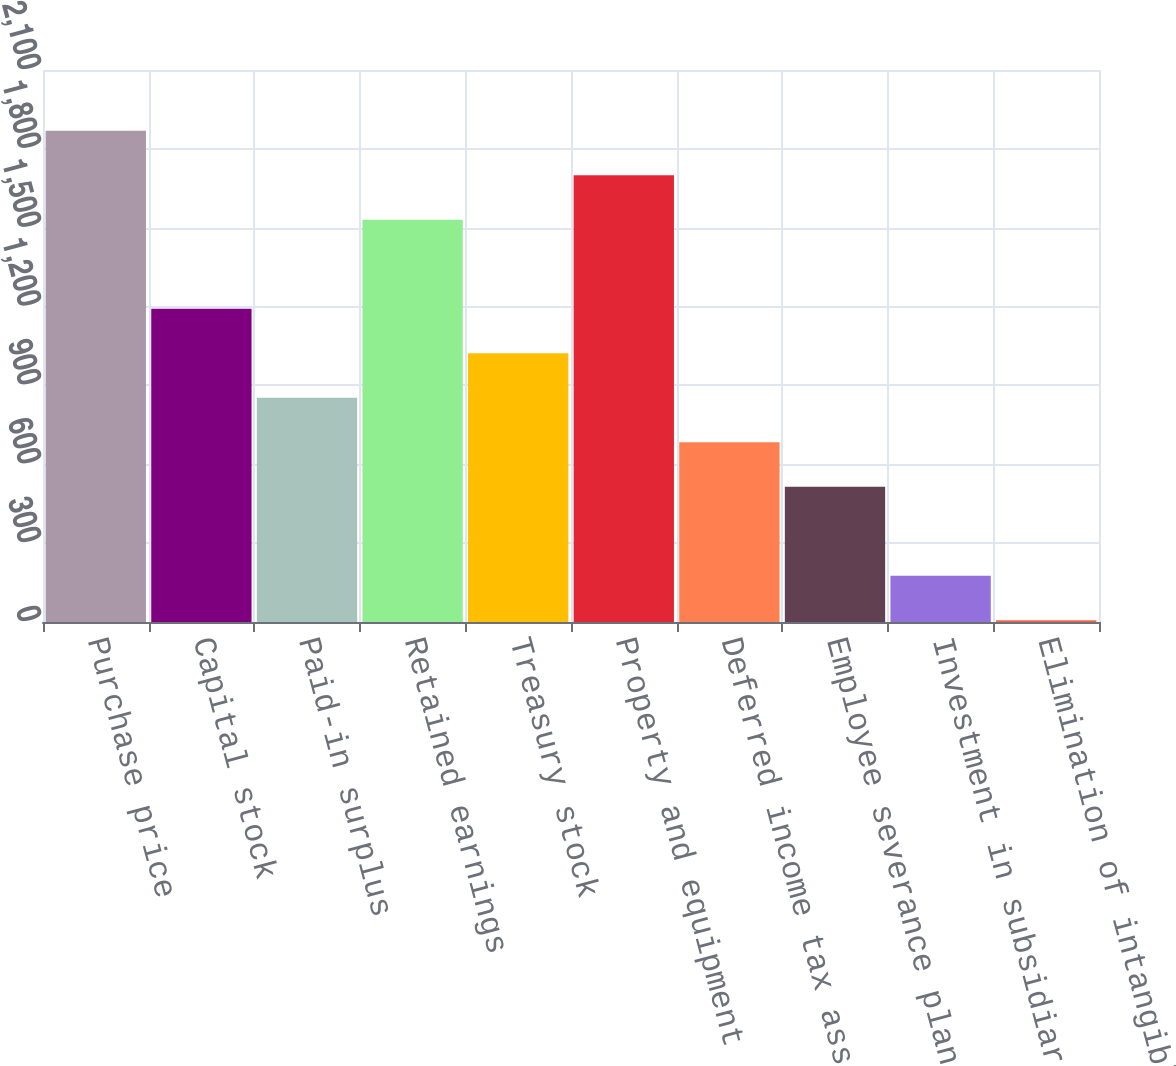<chart> <loc_0><loc_0><loc_500><loc_500><bar_chart><fcel>Purchase price<fcel>Capital stock<fcel>Paid-in surplus<fcel>Retained earnings<fcel>Treasury stock<fcel>Property and equipment<fcel>Deferred income tax asset<fcel>Employee severance plan<fcel>Investment in subsidiaries<fcel>Elimination of intangible<nl><fcel>1869.3<fcel>1192.1<fcel>853.5<fcel>1530.7<fcel>1022.8<fcel>1700<fcel>684.2<fcel>514.9<fcel>176.3<fcel>7<nl></chart> 